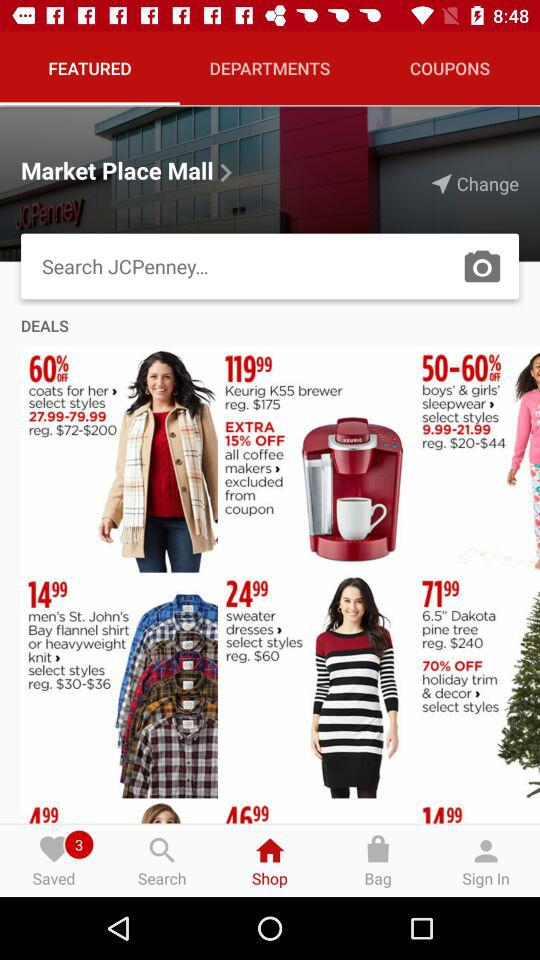What is the off percentage on "coats for her"? The off percentage on "coats for her" is 60. 